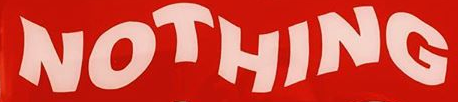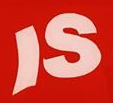What words are shown in these images in order, separated by a semicolon? NOTHING; IS 